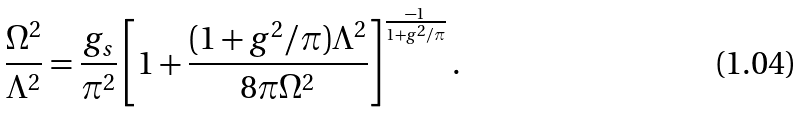<formula> <loc_0><loc_0><loc_500><loc_500>\frac { \Omega ^ { 2 } } { \Lambda ^ { 2 } } = \frac { g _ { s } } { \pi ^ { 2 } } \left [ 1 + \frac { ( 1 + g ^ { 2 } / \pi ) \Lambda ^ { 2 } } { 8 \pi \Omega ^ { 2 } } \right ] ^ { \frac { - 1 } { 1 + g ^ { 2 } / \pi } } .</formula> 